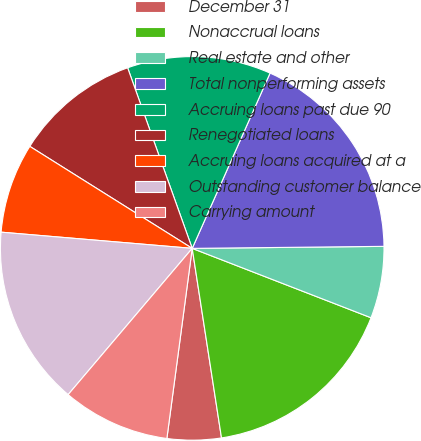Convert chart to OTSL. <chart><loc_0><loc_0><loc_500><loc_500><pie_chart><fcel>December 31<fcel>Nonaccrual loans<fcel>Real estate and other<fcel>Total nonperforming assets<fcel>Accruing loans past due 90<fcel>Renegotiated loans<fcel>Accruing loans acquired at a<fcel>Outstanding customer balance<fcel>Carrying amount<nl><fcel>4.55%<fcel>16.67%<fcel>6.06%<fcel>18.18%<fcel>12.12%<fcel>10.61%<fcel>7.58%<fcel>15.15%<fcel>9.09%<nl></chart> 